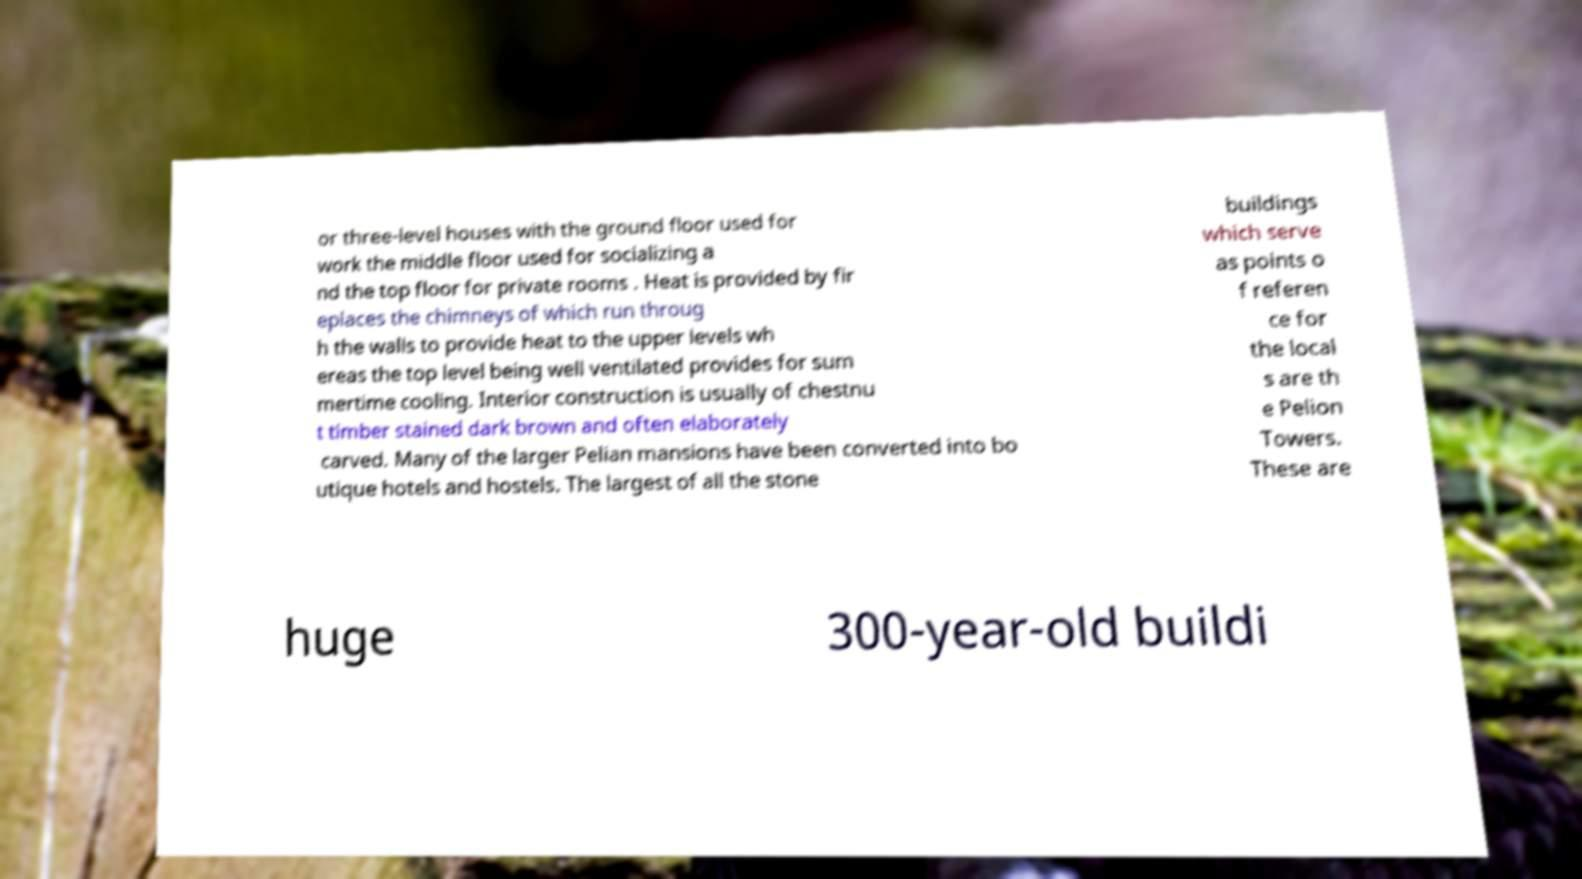Please read and relay the text visible in this image. What does it say? or three-level houses with the ground floor used for work the middle floor used for socializing a nd the top floor for private rooms . Heat is provided by fir eplaces the chimneys of which run throug h the walls to provide heat to the upper levels wh ereas the top level being well ventilated provides for sum mertime cooling. Interior construction is usually of chestnu t timber stained dark brown and often elaborately carved. Many of the larger Pelian mansions have been converted into bo utique hotels and hostels. The largest of all the stone buildings which serve as points o f referen ce for the local s are th e Pelion Towers. These are huge 300-year-old buildi 